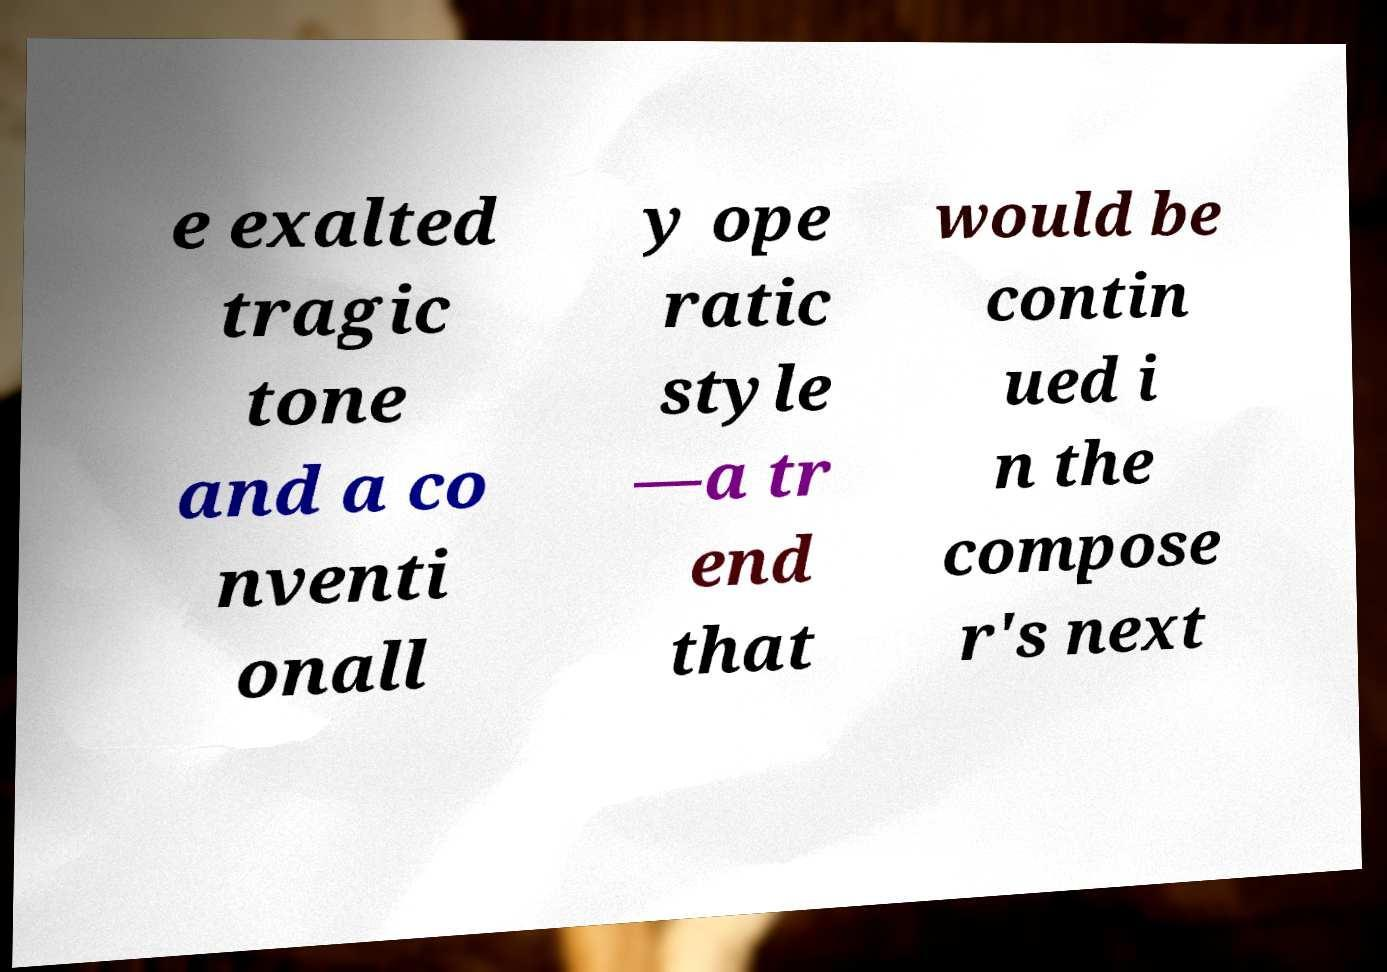Could you extract and type out the text from this image? e exalted tragic tone and a co nventi onall y ope ratic style —a tr end that would be contin ued i n the compose r's next 